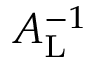<formula> <loc_0><loc_0><loc_500><loc_500>A _ { L } ^ { - 1 }</formula> 